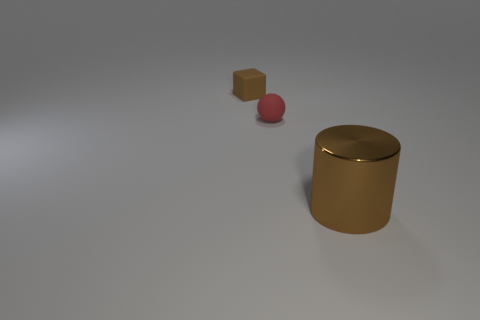Add 2 small red spheres. How many objects exist? 5 Subtract all cubes. How many objects are left? 2 Subtract 1 cylinders. How many cylinders are left? 0 Subtract all purple blocks. Subtract all green spheres. How many blocks are left? 1 Subtract all cyan balls. How many blue blocks are left? 0 Subtract all matte objects. Subtract all green shiny blocks. How many objects are left? 1 Add 3 big shiny cylinders. How many big shiny cylinders are left? 4 Add 2 large green shiny cylinders. How many large green shiny cylinders exist? 2 Subtract 0 gray balls. How many objects are left? 3 